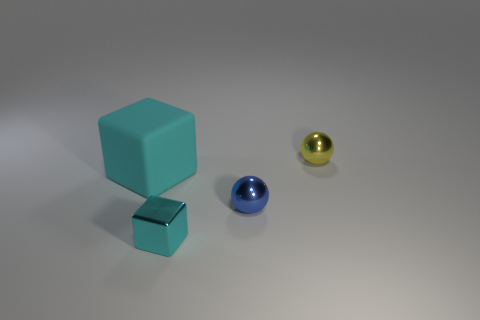Add 3 tiny metal things. How many objects exist? 7 Add 1 cyan metallic cubes. How many cyan metallic cubes exist? 2 Subtract 0 yellow cubes. How many objects are left? 4 Subtract all big matte cubes. Subtract all cyan metal cubes. How many objects are left? 2 Add 2 blue shiny balls. How many blue shiny balls are left? 3 